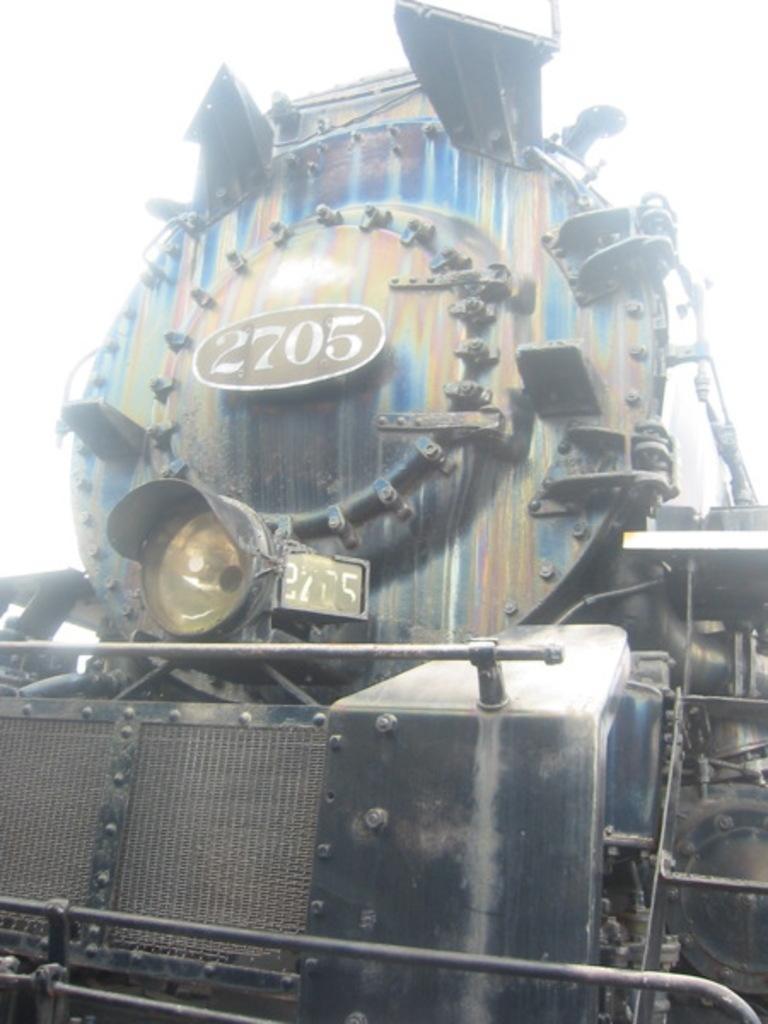In one or two sentences, can you explain what this image depicts? In this image we can see a railway engine and sky in the background. 